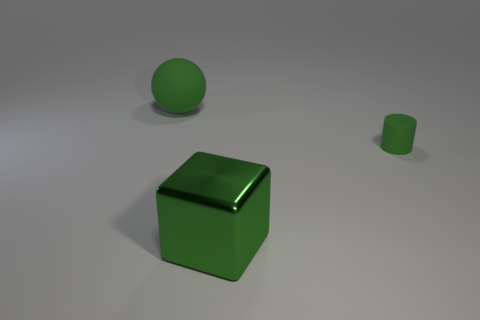Is there anything else that has the same shape as the metallic object?
Your answer should be very brief. No. Do the big green matte object and the rubber thing that is to the right of the big sphere have the same shape?
Offer a very short reply. No. What is the cylinder made of?
Give a very brief answer. Rubber. How many other objects are there of the same material as the ball?
Your response must be concise. 1. Does the large green sphere have the same material as the object in front of the tiny green rubber cylinder?
Provide a short and direct response. No. Are there fewer big green balls that are on the right side of the green rubber cylinder than large green things left of the metallic object?
Offer a very short reply. Yes. There is a matte object that is behind the cylinder; what is its color?
Provide a succinct answer. Green. What number of other objects are there of the same color as the metallic block?
Ensure brevity in your answer.  2. Does the object that is to the left of the green shiny cube have the same size as the green cylinder?
Give a very brief answer. No. There is a large green metal block; what number of green matte things are left of it?
Provide a succinct answer. 1. 